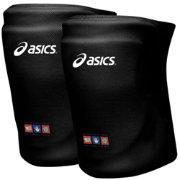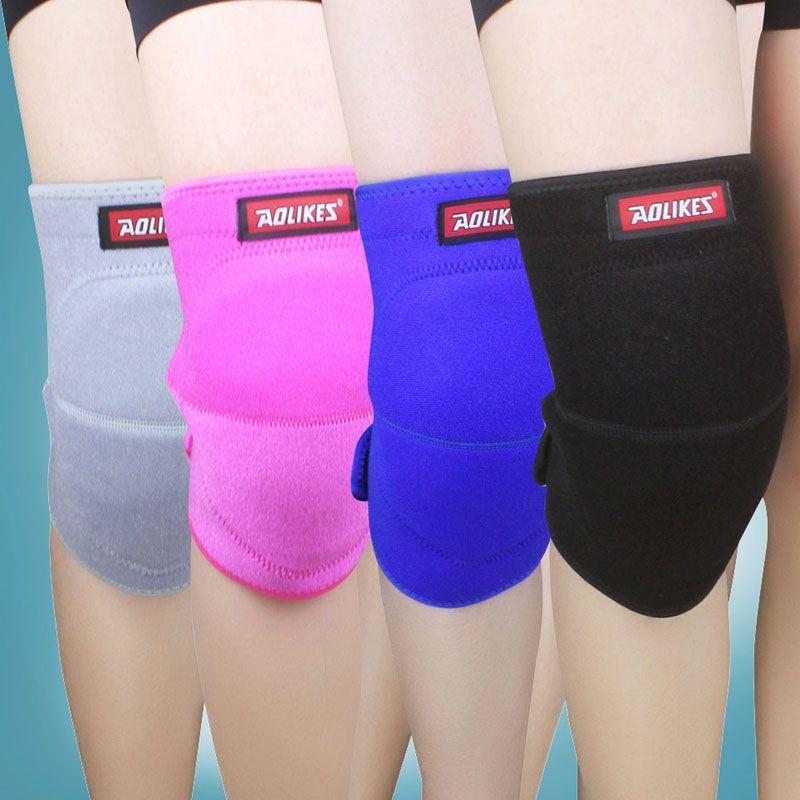The first image is the image on the left, the second image is the image on the right. Evaluate the accuracy of this statement regarding the images: "The knee braces in the left image are facing towards the left.". Is it true? Answer yes or no. Yes. The first image is the image on the left, the second image is the image on the right. Analyze the images presented: Is the assertion "One image contains at least three legs wearing different kneepads." valid? Answer yes or no. Yes. 